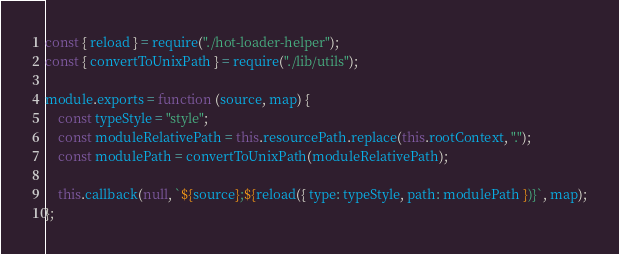Convert code to text. <code><loc_0><loc_0><loc_500><loc_500><_JavaScript_>const { reload } = require("./hot-loader-helper");
const { convertToUnixPath } = require("./lib/utils");

module.exports = function (source, map) {
    const typeStyle = "style";
    const moduleRelativePath = this.resourcePath.replace(this.rootContext, ".");
    const modulePath = convertToUnixPath(moduleRelativePath);

    this.callback(null, `${source};${reload({ type: typeStyle, path: modulePath })}`, map);
};
</code> 